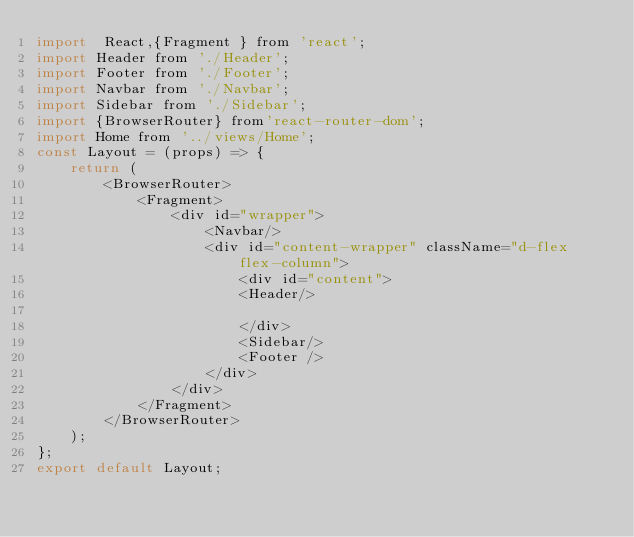Convert code to text. <code><loc_0><loc_0><loc_500><loc_500><_JavaScript_>import  React,{Fragment } from 'react';
import Header from './Header';
import Footer from './Footer';
import Navbar from './Navbar';
import Sidebar from './Sidebar';
import {BrowserRouter} from'react-router-dom';
import Home from '../views/Home'; 
const Layout = (props) => {
    return (
        <BrowserRouter>
            <Fragment>
                <div id="wrapper">  
                    <Navbar/>  
                    <div id="content-wrapper" className="d-flex flex-column">  
                        <div id="content">  
                        <Header/>  
                            
                        </div>  
                        <Sidebar/>
                        <Footer />  
                    </div>  
                </div>  
            </Fragment> 
        </BrowserRouter>
    );
};
export default Layout;
</code> 